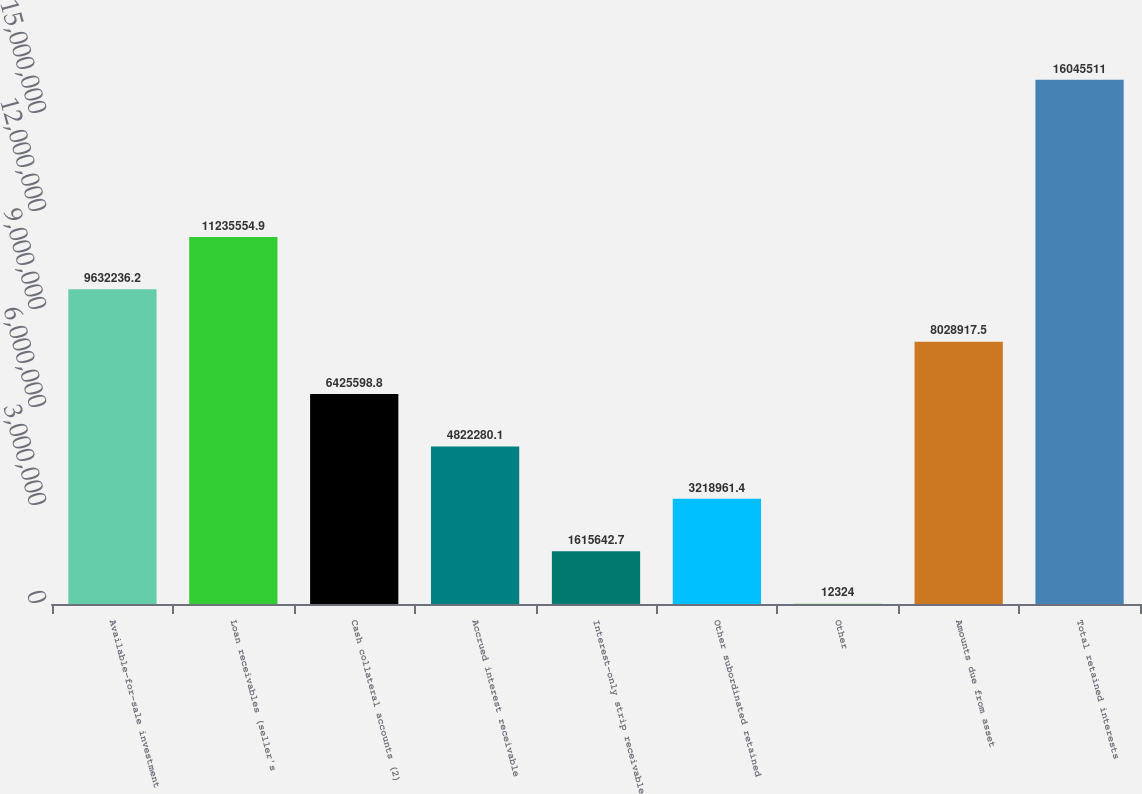Convert chart to OTSL. <chart><loc_0><loc_0><loc_500><loc_500><bar_chart><fcel>Available-for-sale investment<fcel>Loan receivables (seller's<fcel>Cash collateral accounts (2)<fcel>Accrued interest receivable<fcel>Interest-only strip receivable<fcel>Other subordinated retained<fcel>Other<fcel>Amounts due from asset<fcel>Total retained interests<nl><fcel>9.63224e+06<fcel>1.12356e+07<fcel>6.4256e+06<fcel>4.82228e+06<fcel>1.61564e+06<fcel>3.21896e+06<fcel>12324<fcel>8.02892e+06<fcel>1.60455e+07<nl></chart> 